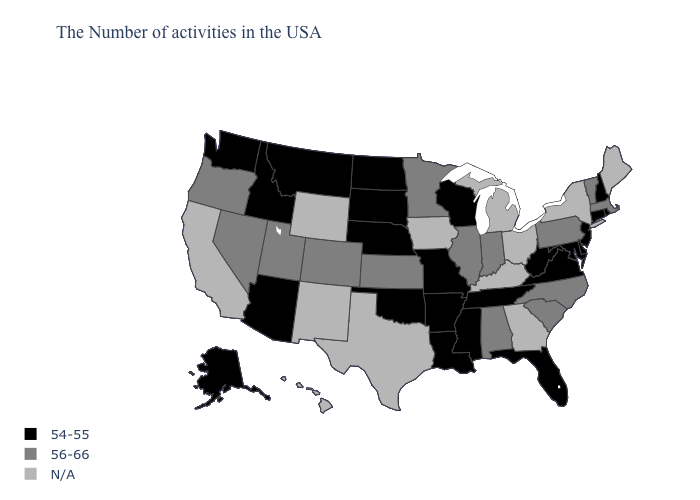What is the value of Oklahoma?
Be succinct. 54-55. What is the lowest value in states that border Rhode Island?
Write a very short answer. 54-55. What is the lowest value in the USA?
Concise answer only. 54-55. What is the highest value in states that border Oklahoma?
Quick response, please. 56-66. Which states have the lowest value in the West?
Concise answer only. Montana, Arizona, Idaho, Washington, Alaska. Which states hav the highest value in the South?
Write a very short answer. North Carolina, South Carolina, Alabama. What is the value of Maryland?
Keep it brief. 54-55. What is the value of Idaho?
Keep it brief. 54-55. Which states have the highest value in the USA?
Concise answer only. Massachusetts, Vermont, Pennsylvania, North Carolina, South Carolina, Indiana, Alabama, Illinois, Minnesota, Kansas, Colorado, Utah, Nevada, Oregon. Name the states that have a value in the range N/A?
Quick response, please. Maine, New York, Ohio, Georgia, Michigan, Kentucky, Iowa, Texas, Wyoming, New Mexico, California, Hawaii. What is the highest value in the USA?
Write a very short answer. 56-66. Does New Jersey have the highest value in the USA?
Give a very brief answer. No. Does the map have missing data?
Write a very short answer. Yes. Among the states that border South Carolina , which have the lowest value?
Keep it brief. North Carolina. 